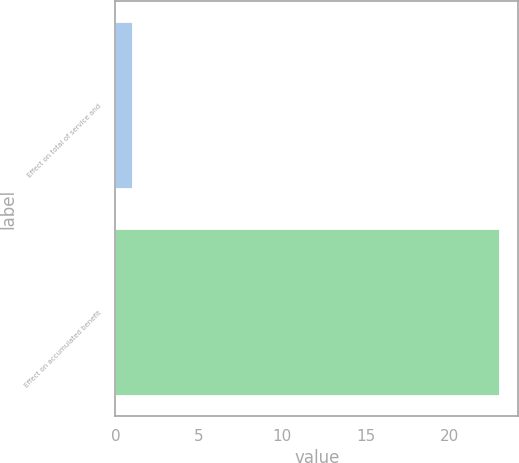<chart> <loc_0><loc_0><loc_500><loc_500><bar_chart><fcel>Effect on total of service and<fcel>Effect on accumulated benefit<nl><fcel>1<fcel>23<nl></chart> 